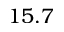Convert formula to latex. <formula><loc_0><loc_0><loc_500><loc_500>1 5 . 7</formula> 